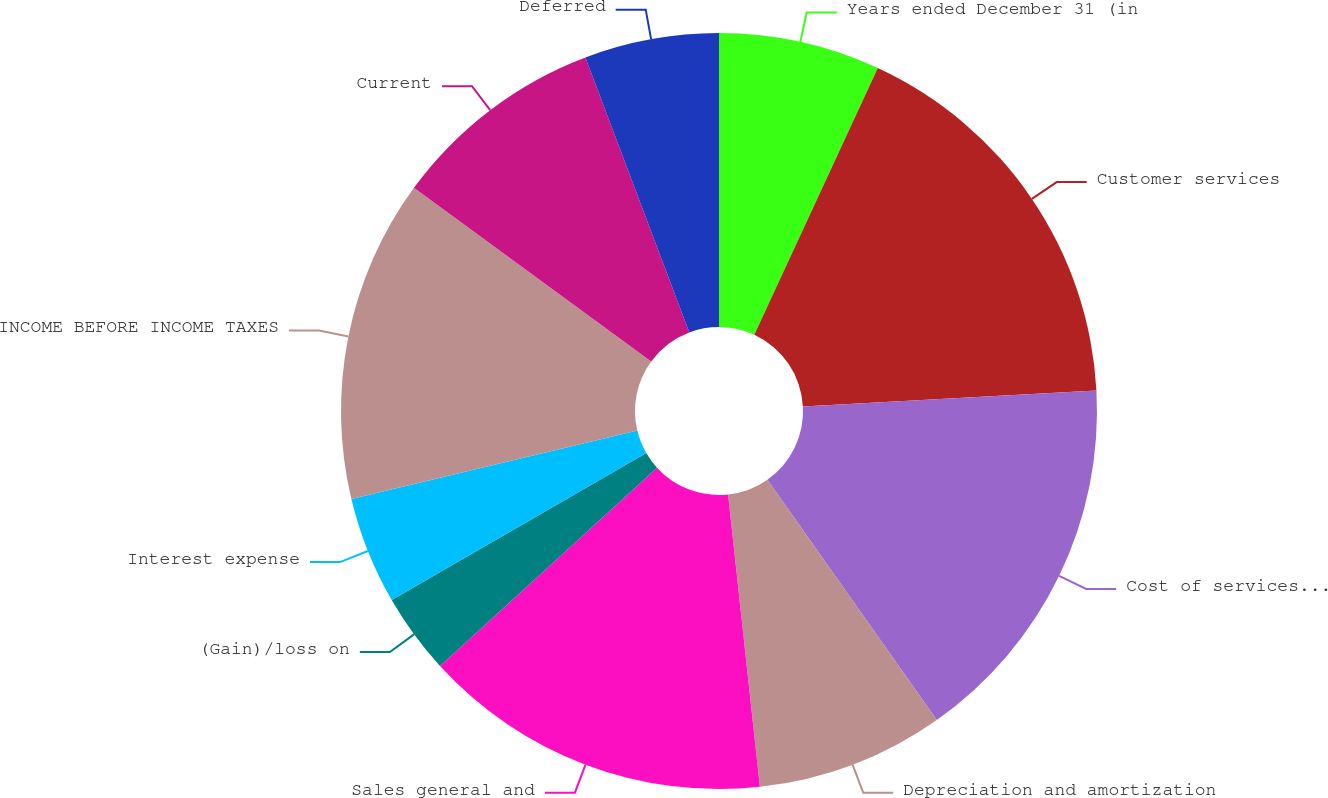<chart> <loc_0><loc_0><loc_500><loc_500><pie_chart><fcel>Years ended December 31 (in<fcel>Customer services<fcel>Cost of services provided<fcel>Depreciation and amortization<fcel>Sales general and<fcel>(Gain)/loss on<fcel>Interest expense<fcel>INCOME BEFORE INCOME TAXES<fcel>Current<fcel>Deferred<nl><fcel>6.9%<fcel>17.24%<fcel>16.09%<fcel>8.05%<fcel>14.94%<fcel>3.45%<fcel>4.6%<fcel>13.79%<fcel>9.2%<fcel>5.75%<nl></chart> 